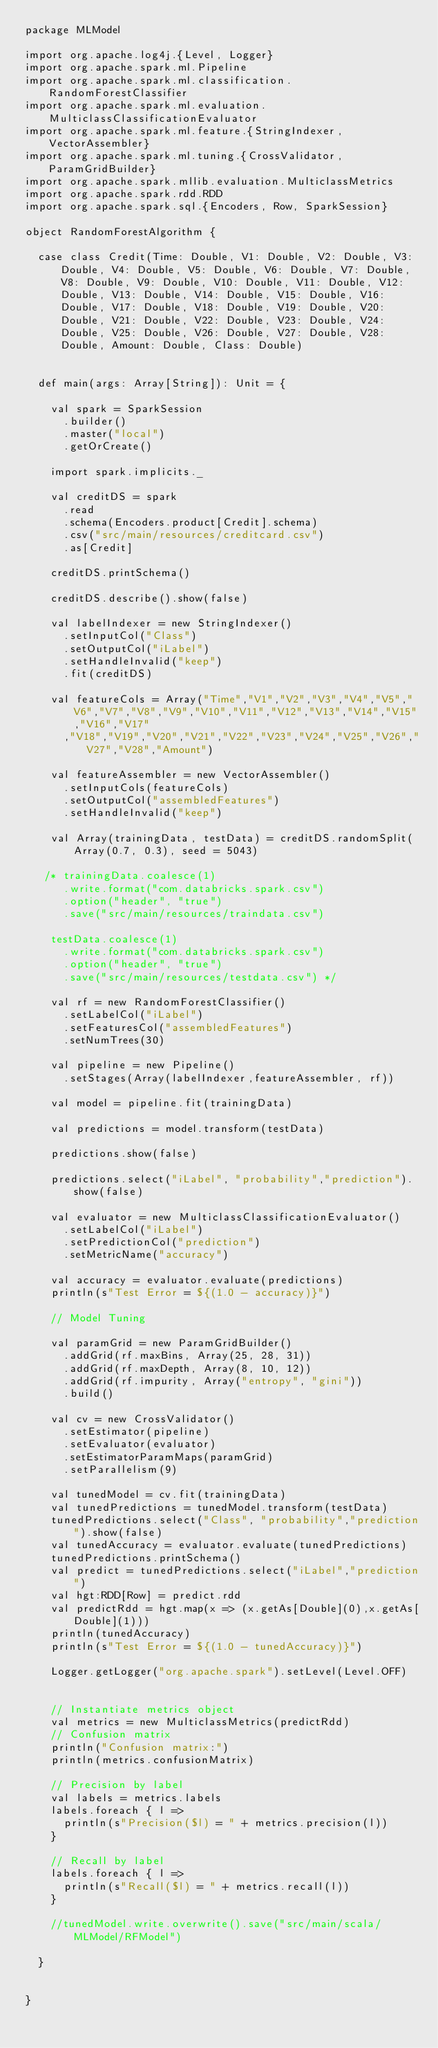Convert code to text. <code><loc_0><loc_0><loc_500><loc_500><_Scala_>package MLModel

import org.apache.log4j.{Level, Logger}
import org.apache.spark.ml.Pipeline
import org.apache.spark.ml.classification.RandomForestClassifier
import org.apache.spark.ml.evaluation.MulticlassClassificationEvaluator
import org.apache.spark.ml.feature.{StringIndexer, VectorAssembler}
import org.apache.spark.ml.tuning.{CrossValidator, ParamGridBuilder}
import org.apache.spark.mllib.evaluation.MulticlassMetrics
import org.apache.spark.rdd.RDD
import org.apache.spark.sql.{Encoders, Row, SparkSession}

object RandomForestAlgorithm {

  case class Credit(Time: Double, V1: Double, V2: Double, V3: Double, V4: Double, V5: Double, V6: Double, V7: Double, V8: Double, V9: Double, V10: Double, V11: Double, V12: Double, V13: Double, V14: Double, V15: Double, V16: Double, V17: Double, V18: Double, V19: Double, V20: Double, V21: Double, V22: Double, V23: Double, V24: Double, V25: Double, V26: Double, V27: Double, V28: Double, Amount: Double, Class: Double)


  def main(args: Array[String]): Unit = {

    val spark = SparkSession
      .builder()
      .master("local")
      .getOrCreate()

    import spark.implicits._

    val creditDS = spark
      .read
      .schema(Encoders.product[Credit].schema)
      .csv("src/main/resources/creditcard.csv")
      .as[Credit]

    creditDS.printSchema()

    creditDS.describe().show(false)

    val labelIndexer = new StringIndexer()
      .setInputCol("Class")
      .setOutputCol("iLabel")
      .setHandleInvalid("keep")
      .fit(creditDS)

    val featureCols = Array("Time","V1","V2","V3","V4","V5","V6","V7","V8","V9","V10","V11","V12","V13","V14","V15","V16","V17"
      ,"V18","V19","V20","V21","V22","V23","V24","V25","V26","V27","V28","Amount")

    val featureAssembler = new VectorAssembler()
      .setInputCols(featureCols)
      .setOutputCol("assembledFeatures")
      .setHandleInvalid("keep")

    val Array(trainingData, testData) = creditDS.randomSplit(Array(0.7, 0.3), seed = 5043)

   /* trainingData.coalesce(1)
      .write.format("com.databricks.spark.csv")
      .option("header", "true")
      .save("src/main/resources/traindata.csv")

    testData.coalesce(1)
      .write.format("com.databricks.spark.csv")
      .option("header", "true")
      .save("src/main/resources/testdata.csv") */

    val rf = new RandomForestClassifier()
      .setLabelCol("iLabel")
      .setFeaturesCol("assembledFeatures")
      .setNumTrees(30)

    val pipeline = new Pipeline()
      .setStages(Array(labelIndexer,featureAssembler, rf))

    val model = pipeline.fit(trainingData)

    val predictions = model.transform(testData)

    predictions.show(false)

    predictions.select("iLabel", "probability","prediction").show(false)

    val evaluator = new MulticlassClassificationEvaluator()
      .setLabelCol("iLabel")
      .setPredictionCol("prediction")
      .setMetricName("accuracy")

    val accuracy = evaluator.evaluate(predictions)
    println(s"Test Error = ${(1.0 - accuracy)}")

    // Model Tuning

    val paramGrid = new ParamGridBuilder()
      .addGrid(rf.maxBins, Array(25, 28, 31))
      .addGrid(rf.maxDepth, Array(8, 10, 12))
      .addGrid(rf.impurity, Array("entropy", "gini"))
      .build()

    val cv = new CrossValidator()
      .setEstimator(pipeline)
      .setEvaluator(evaluator)
      .setEstimatorParamMaps(paramGrid)
      .setParallelism(9)

    val tunedModel = cv.fit(trainingData)
    val tunedPredictions = tunedModel.transform(testData)
    tunedPredictions.select("Class", "probability","prediction").show(false)
    val tunedAccuracy = evaluator.evaluate(tunedPredictions)
    tunedPredictions.printSchema()
    val predict = tunedPredictions.select("iLabel","prediction")
    val hgt:RDD[Row] = predict.rdd
    val predictRdd = hgt.map(x => (x.getAs[Double](0),x.getAs[Double](1)))
    println(tunedAccuracy)
    println(s"Test Error = ${(1.0 - tunedAccuracy)}")

    Logger.getLogger("org.apache.spark").setLevel(Level.OFF)


    // Instantiate metrics object
    val metrics = new MulticlassMetrics(predictRdd)
    // Confusion matrix
    println("Confusion matrix:")
    println(metrics.confusionMatrix)

    // Precision by label
    val labels = metrics.labels
    labels.foreach { l =>
      println(s"Precision($l) = " + metrics.precision(l))
    }

    // Recall by label
    labels.foreach { l =>
      println(s"Recall($l) = " + metrics.recall(l))
    }

    //tunedModel.write.overwrite().save("src/main/scala/MLModel/RFModel")

  }


}
</code> 